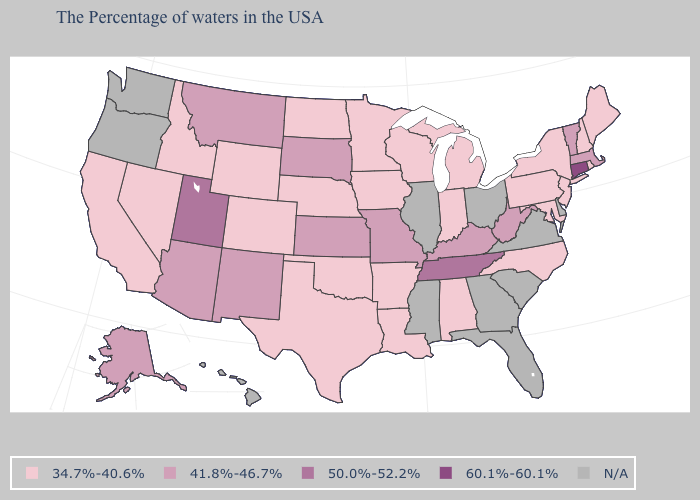Does Kansas have the lowest value in the USA?
Write a very short answer. No. What is the lowest value in the USA?
Answer briefly. 34.7%-40.6%. Is the legend a continuous bar?
Short answer required. No. Among the states that border New Hampshire , which have the lowest value?
Concise answer only. Maine. What is the highest value in the USA?
Quick response, please. 60.1%-60.1%. What is the value of Idaho?
Quick response, please. 34.7%-40.6%. What is the highest value in states that border Maryland?
Give a very brief answer. 41.8%-46.7%. What is the value of California?
Concise answer only. 34.7%-40.6%. Does Maryland have the highest value in the South?
Quick response, please. No. Is the legend a continuous bar?
Answer briefly. No. Does the first symbol in the legend represent the smallest category?
Write a very short answer. Yes. Name the states that have a value in the range 60.1%-60.1%?
Keep it brief. Connecticut. Does the first symbol in the legend represent the smallest category?
Give a very brief answer. Yes. What is the value of Connecticut?
Short answer required. 60.1%-60.1%. 